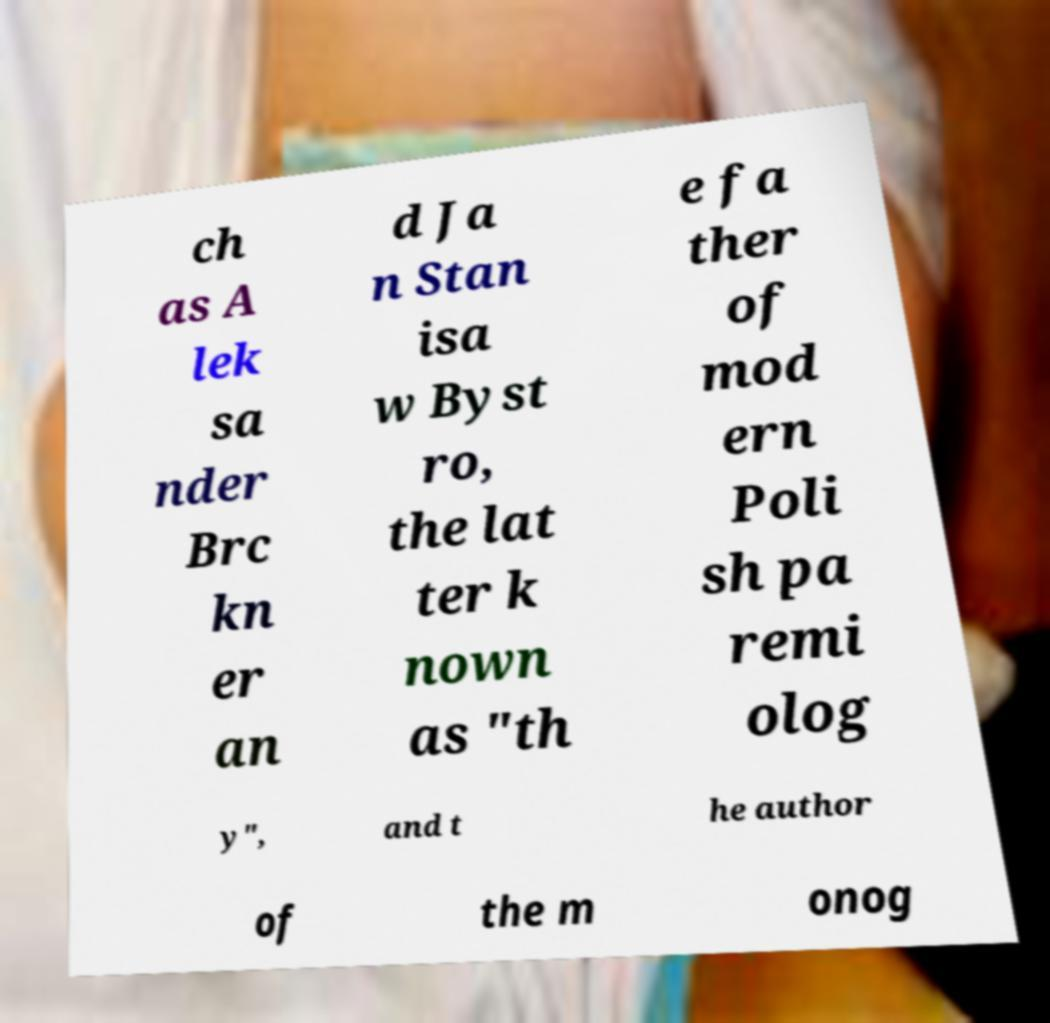What messages or text are displayed in this image? I need them in a readable, typed format. ch as A lek sa nder Brc kn er an d Ja n Stan isa w Byst ro, the lat ter k nown as "th e fa ther of mod ern Poli sh pa remi olog y", and t he author of the m onog 